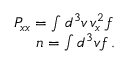Convert formula to latex. <formula><loc_0><loc_0><loc_500><loc_500>\begin{array} { r } { P _ { x x } = \int d ^ { 3 } v \, v _ { x } ^ { 2 } f \, } \\ { n = \int d ^ { 3 } v f \, . } \end{array}</formula> 